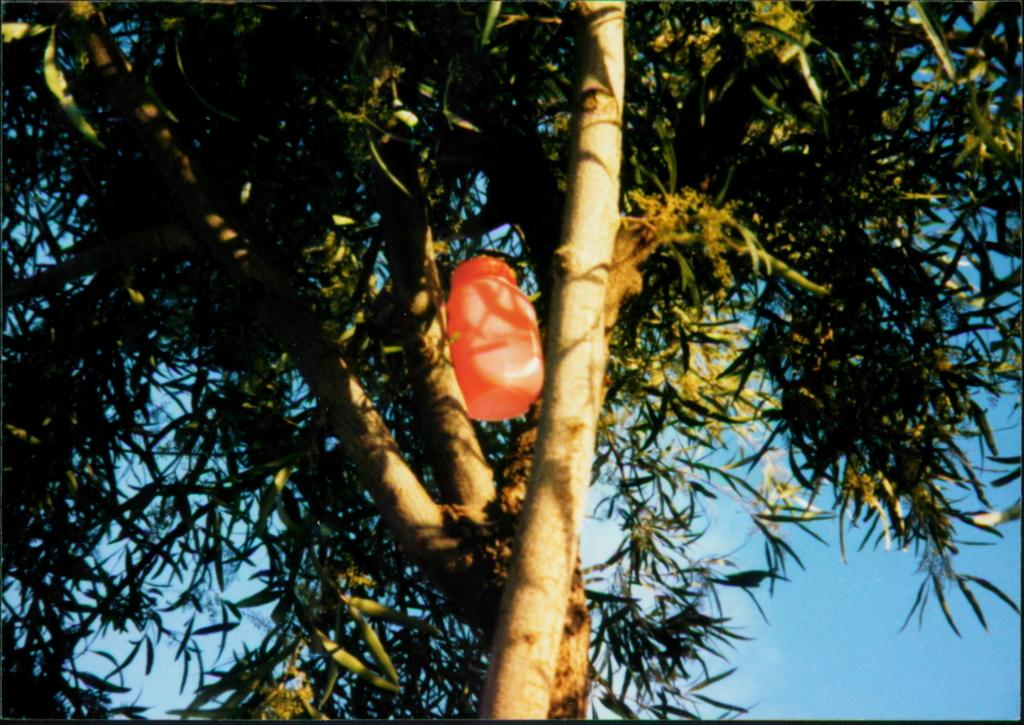What is the main object in the image? There is a tree in the image. Is there anything on the tree? Yes, there is an object on the branch of the tree. What can be seen in the sky in the image? The sky is clear in the image. How many eggs are visible on the tree in the image? There are no eggs present in the image. What type of apparatus is hanging from the tree in the image? There is no apparatus hanging from the tree in the image; only an object is mentioned. Is there a visitor sitting under the tree in the image? There is no visitor present in the image. 